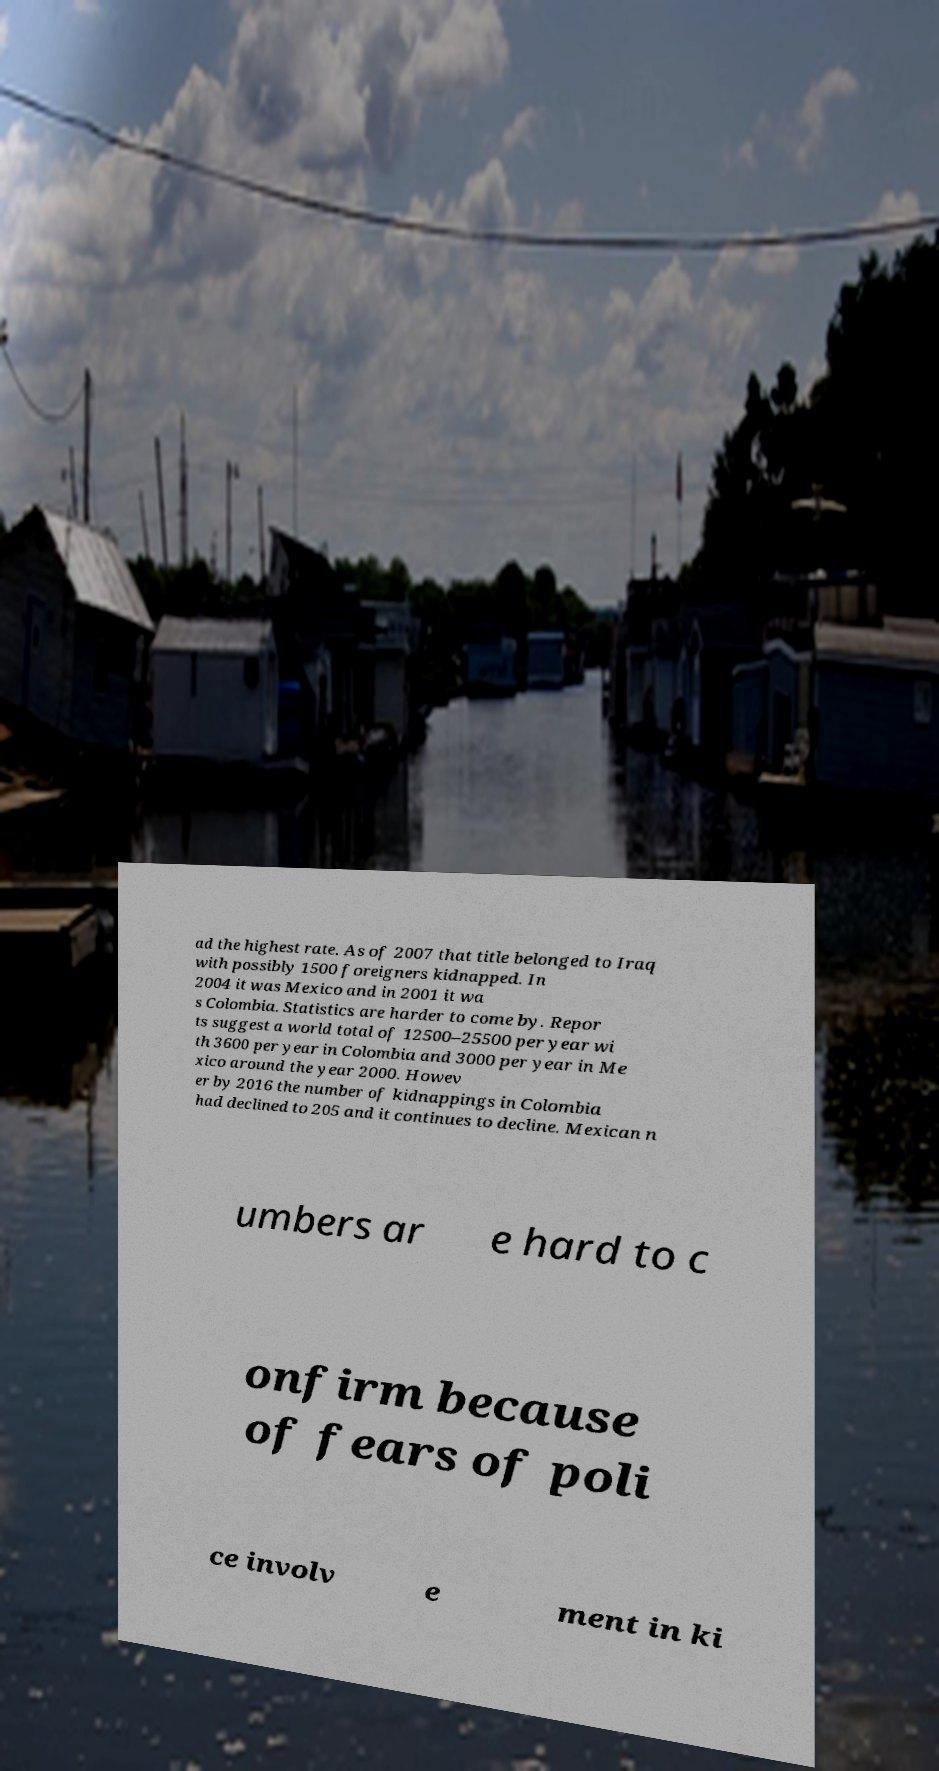Could you assist in decoding the text presented in this image and type it out clearly? ad the highest rate. As of 2007 that title belonged to Iraq with possibly 1500 foreigners kidnapped. In 2004 it was Mexico and in 2001 it wa s Colombia. Statistics are harder to come by. Repor ts suggest a world total of 12500–25500 per year wi th 3600 per year in Colombia and 3000 per year in Me xico around the year 2000. Howev er by 2016 the number of kidnappings in Colombia had declined to 205 and it continues to decline. Mexican n umbers ar e hard to c onfirm because of fears of poli ce involv e ment in ki 